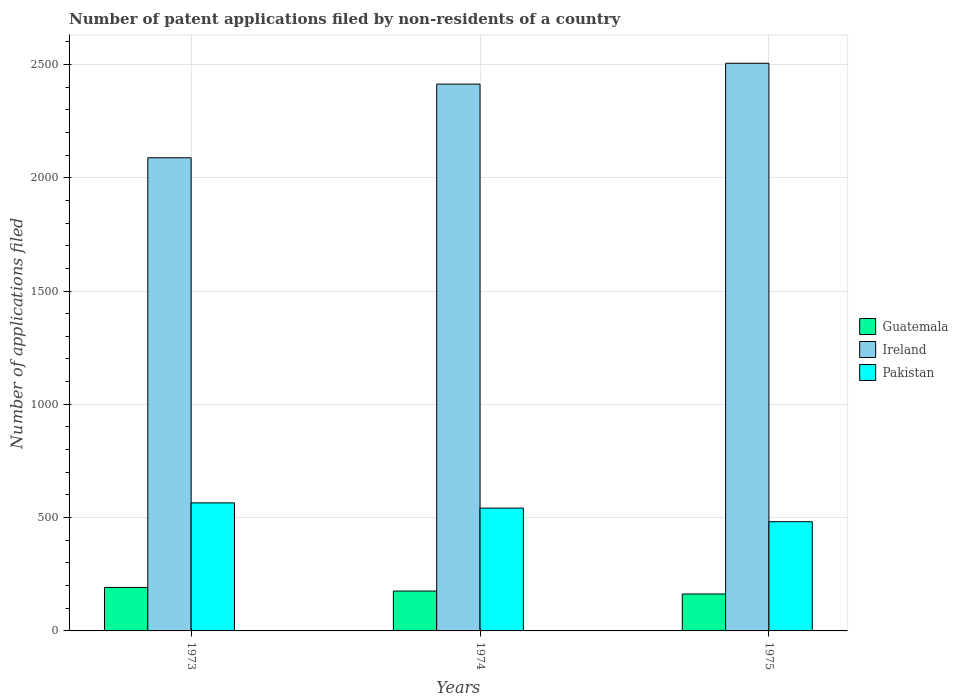Are the number of bars per tick equal to the number of legend labels?
Make the answer very short. Yes. Are the number of bars on each tick of the X-axis equal?
Your answer should be compact. Yes. What is the label of the 3rd group of bars from the left?
Offer a terse response. 1975. In how many cases, is the number of bars for a given year not equal to the number of legend labels?
Your response must be concise. 0. What is the number of applications filed in Ireland in 1975?
Your response must be concise. 2505. Across all years, what is the maximum number of applications filed in Guatemala?
Keep it short and to the point. 192. Across all years, what is the minimum number of applications filed in Pakistan?
Keep it short and to the point. 482. In which year was the number of applications filed in Ireland minimum?
Your response must be concise. 1973. What is the total number of applications filed in Pakistan in the graph?
Your response must be concise. 1589. What is the difference between the number of applications filed in Pakistan in 1973 and the number of applications filed in Guatemala in 1974?
Offer a very short reply. 389. What is the average number of applications filed in Ireland per year?
Offer a terse response. 2335.33. In the year 1973, what is the difference between the number of applications filed in Guatemala and number of applications filed in Ireland?
Provide a short and direct response. -1896. In how many years, is the number of applications filed in Ireland greater than 2300?
Offer a terse response. 2. What is the ratio of the number of applications filed in Ireland in 1973 to that in 1975?
Give a very brief answer. 0.83. Is the number of applications filed in Ireland in 1974 less than that in 1975?
Offer a very short reply. Yes. What is the difference between the highest and the second highest number of applications filed in Pakistan?
Offer a very short reply. 23. What is the difference between the highest and the lowest number of applications filed in Pakistan?
Your answer should be compact. 83. In how many years, is the number of applications filed in Pakistan greater than the average number of applications filed in Pakistan taken over all years?
Keep it short and to the point. 2. What does the 2nd bar from the left in 1973 represents?
Provide a succinct answer. Ireland. What does the 3rd bar from the right in 1975 represents?
Your answer should be compact. Guatemala. How many bars are there?
Your answer should be very brief. 9. Does the graph contain grids?
Make the answer very short. Yes. How many legend labels are there?
Provide a short and direct response. 3. What is the title of the graph?
Your answer should be very brief. Number of patent applications filed by non-residents of a country. Does "Mongolia" appear as one of the legend labels in the graph?
Provide a short and direct response. No. What is the label or title of the Y-axis?
Your answer should be very brief. Number of applications filed. What is the Number of applications filed of Guatemala in 1973?
Provide a short and direct response. 192. What is the Number of applications filed of Ireland in 1973?
Provide a short and direct response. 2088. What is the Number of applications filed of Pakistan in 1973?
Your response must be concise. 565. What is the Number of applications filed in Guatemala in 1974?
Your answer should be compact. 176. What is the Number of applications filed in Ireland in 1974?
Keep it short and to the point. 2413. What is the Number of applications filed in Pakistan in 1974?
Give a very brief answer. 542. What is the Number of applications filed in Guatemala in 1975?
Provide a short and direct response. 163. What is the Number of applications filed of Ireland in 1975?
Give a very brief answer. 2505. What is the Number of applications filed of Pakistan in 1975?
Give a very brief answer. 482. Across all years, what is the maximum Number of applications filed of Guatemala?
Ensure brevity in your answer.  192. Across all years, what is the maximum Number of applications filed in Ireland?
Keep it short and to the point. 2505. Across all years, what is the maximum Number of applications filed in Pakistan?
Your answer should be very brief. 565. Across all years, what is the minimum Number of applications filed of Guatemala?
Your response must be concise. 163. Across all years, what is the minimum Number of applications filed in Ireland?
Ensure brevity in your answer.  2088. Across all years, what is the minimum Number of applications filed of Pakistan?
Your answer should be compact. 482. What is the total Number of applications filed of Guatemala in the graph?
Give a very brief answer. 531. What is the total Number of applications filed in Ireland in the graph?
Make the answer very short. 7006. What is the total Number of applications filed of Pakistan in the graph?
Give a very brief answer. 1589. What is the difference between the Number of applications filed in Guatemala in 1973 and that in 1974?
Ensure brevity in your answer.  16. What is the difference between the Number of applications filed of Ireland in 1973 and that in 1974?
Provide a short and direct response. -325. What is the difference between the Number of applications filed in Guatemala in 1973 and that in 1975?
Keep it short and to the point. 29. What is the difference between the Number of applications filed of Ireland in 1973 and that in 1975?
Ensure brevity in your answer.  -417. What is the difference between the Number of applications filed in Pakistan in 1973 and that in 1975?
Provide a short and direct response. 83. What is the difference between the Number of applications filed of Guatemala in 1974 and that in 1975?
Offer a very short reply. 13. What is the difference between the Number of applications filed in Ireland in 1974 and that in 1975?
Make the answer very short. -92. What is the difference between the Number of applications filed of Pakistan in 1974 and that in 1975?
Offer a terse response. 60. What is the difference between the Number of applications filed in Guatemala in 1973 and the Number of applications filed in Ireland in 1974?
Give a very brief answer. -2221. What is the difference between the Number of applications filed of Guatemala in 1973 and the Number of applications filed of Pakistan in 1974?
Provide a succinct answer. -350. What is the difference between the Number of applications filed of Ireland in 1973 and the Number of applications filed of Pakistan in 1974?
Offer a very short reply. 1546. What is the difference between the Number of applications filed of Guatemala in 1973 and the Number of applications filed of Ireland in 1975?
Give a very brief answer. -2313. What is the difference between the Number of applications filed of Guatemala in 1973 and the Number of applications filed of Pakistan in 1975?
Keep it short and to the point. -290. What is the difference between the Number of applications filed in Ireland in 1973 and the Number of applications filed in Pakistan in 1975?
Provide a succinct answer. 1606. What is the difference between the Number of applications filed of Guatemala in 1974 and the Number of applications filed of Ireland in 1975?
Give a very brief answer. -2329. What is the difference between the Number of applications filed of Guatemala in 1974 and the Number of applications filed of Pakistan in 1975?
Offer a very short reply. -306. What is the difference between the Number of applications filed of Ireland in 1974 and the Number of applications filed of Pakistan in 1975?
Offer a terse response. 1931. What is the average Number of applications filed in Guatemala per year?
Provide a succinct answer. 177. What is the average Number of applications filed of Ireland per year?
Your answer should be compact. 2335.33. What is the average Number of applications filed in Pakistan per year?
Give a very brief answer. 529.67. In the year 1973, what is the difference between the Number of applications filed of Guatemala and Number of applications filed of Ireland?
Your response must be concise. -1896. In the year 1973, what is the difference between the Number of applications filed in Guatemala and Number of applications filed in Pakistan?
Your response must be concise. -373. In the year 1973, what is the difference between the Number of applications filed of Ireland and Number of applications filed of Pakistan?
Provide a succinct answer. 1523. In the year 1974, what is the difference between the Number of applications filed of Guatemala and Number of applications filed of Ireland?
Make the answer very short. -2237. In the year 1974, what is the difference between the Number of applications filed of Guatemala and Number of applications filed of Pakistan?
Your answer should be compact. -366. In the year 1974, what is the difference between the Number of applications filed in Ireland and Number of applications filed in Pakistan?
Offer a terse response. 1871. In the year 1975, what is the difference between the Number of applications filed in Guatemala and Number of applications filed in Ireland?
Provide a short and direct response. -2342. In the year 1975, what is the difference between the Number of applications filed in Guatemala and Number of applications filed in Pakistan?
Keep it short and to the point. -319. In the year 1975, what is the difference between the Number of applications filed of Ireland and Number of applications filed of Pakistan?
Your response must be concise. 2023. What is the ratio of the Number of applications filed in Guatemala in 1973 to that in 1974?
Provide a short and direct response. 1.09. What is the ratio of the Number of applications filed in Ireland in 1973 to that in 1974?
Provide a short and direct response. 0.87. What is the ratio of the Number of applications filed in Pakistan in 1973 to that in 1974?
Your answer should be very brief. 1.04. What is the ratio of the Number of applications filed in Guatemala in 1973 to that in 1975?
Your response must be concise. 1.18. What is the ratio of the Number of applications filed in Ireland in 1973 to that in 1975?
Ensure brevity in your answer.  0.83. What is the ratio of the Number of applications filed in Pakistan in 1973 to that in 1975?
Provide a short and direct response. 1.17. What is the ratio of the Number of applications filed in Guatemala in 1974 to that in 1975?
Give a very brief answer. 1.08. What is the ratio of the Number of applications filed in Ireland in 1974 to that in 1975?
Give a very brief answer. 0.96. What is the ratio of the Number of applications filed in Pakistan in 1974 to that in 1975?
Your answer should be very brief. 1.12. What is the difference between the highest and the second highest Number of applications filed in Ireland?
Your answer should be compact. 92. What is the difference between the highest and the lowest Number of applications filed of Guatemala?
Offer a terse response. 29. What is the difference between the highest and the lowest Number of applications filed in Ireland?
Your answer should be very brief. 417. What is the difference between the highest and the lowest Number of applications filed in Pakistan?
Your answer should be compact. 83. 